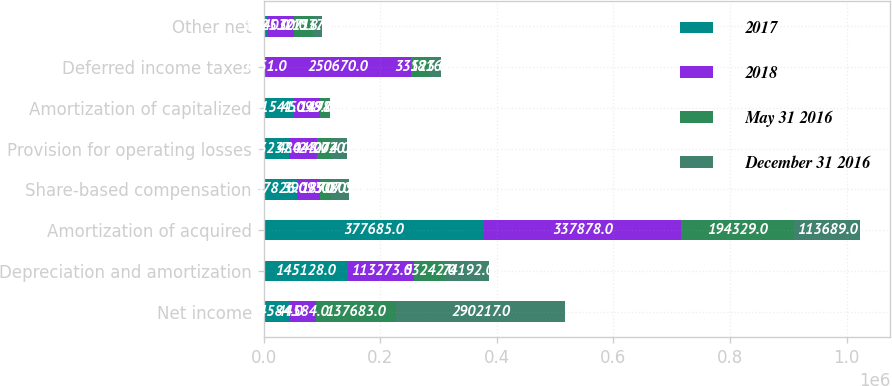Convert chart. <chart><loc_0><loc_0><loc_500><loc_500><stacked_bar_chart><ecel><fcel>Net income<fcel>Depreciation and amortization<fcel>Amortization of acquired<fcel>Share-based compensation<fcel>Provision for operating losses<fcel>Amortization of capitalized<fcel>Deferred income taxes<fcel>Other net<nl><fcel>2017<fcel>44584<fcel>145128<fcel>377685<fcel>57826<fcel>43237<fcel>51541<fcel>1451<fcel>8025<nl><fcel>2018<fcel>44584<fcel>113273<fcel>337878<fcel>39095<fcel>48443<fcel>45098<fcel>250670<fcel>44070<nl><fcel>May 31 2016<fcel>137683<fcel>53242<fcel>194329<fcel>18707<fcel>24074<fcel>14982<fcel>33523<fcel>32718<nl><fcel>December 31 2016<fcel>290217<fcel>74192<fcel>113689<fcel>30809<fcel>27202<fcel>1776<fcel>18162<fcel>15370<nl></chart> 